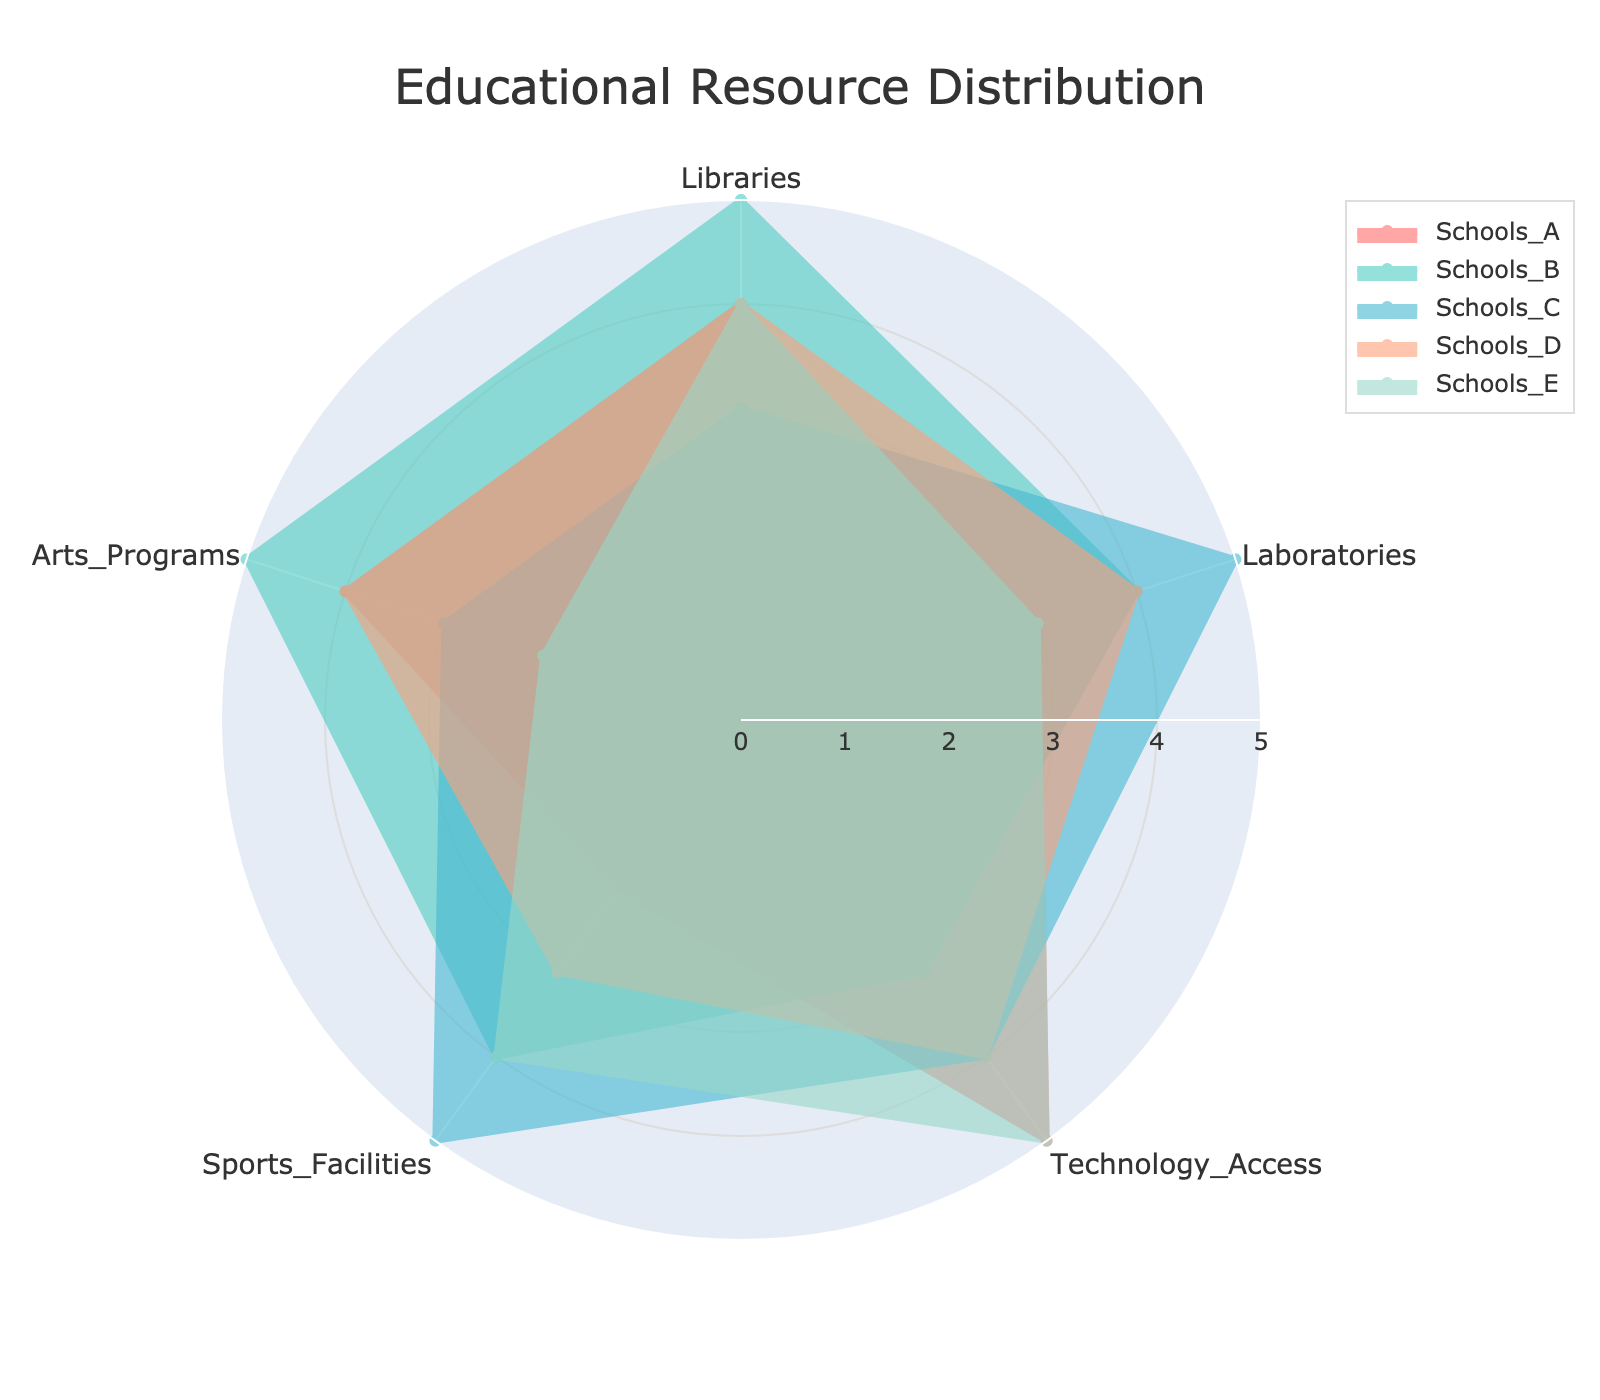What's the title of the radar chart? The title is usually placed at the top center of the figure. In this case, the title is given as "Educational Resource Distribution".
Answer: Educational Resource Distribution Which school has the highest rating for Laboratories? The category Laboratories has ratings from multiple schools. By visually comparing, School C has a rating of 5, which is the highest.
Answer: School C How many categories are there in the radar chart? The categories listed at the ends of the axes are five: Libraries, Laboratories, Technology Access, Sports Facilities, and Arts Programs.
Answer: 5 Which school scores the lowest in Sports Facilities, and what is the score? We need to look at the axis labeled Sports Facilities. School A has a score of 2, which is the lowest among all schools.
Answer: School A, 2 Which school has the most balanced distribution across all categories? A balanced distribution would mean the plotted area is almost circular. School D appears to have relatively even scores across all categories, with most values around 4.
Answer: School D What is the average score of School B across all categories? Adding School B's scores: 5 (Libraries) + 4 (Laboratories) + 3 (Technology Access) + 4 (Sports Facilities) + 5 (Arts Programs) totals 21. Dividing by 5 categories, the average is 21/5 = 4.2.
Answer: 4.2 Which category shows the greatest variation across different schools? We need to compare the range of scores across schools for each category. Sports Facilities have scores ranging from 2 to 5, which shows high variation.
Answer: Sports Facilities Compare the scores of Library resources between School A and School E. For Libraries, School A has a score of 4 and School E has a score of 4. Both scores are equal.
Answer: Equal (4 each) What is the total score for School E across all categories? Summing the scores of School E: 4 (Libraries) + 3 (Laboratories) + 5 (Technology Access) + 4 (Sports Facilities) + 2 (Arts Programs) totals 18.
Answer: 18 Which school has the highest overall score, considering all categories? We calculate the total score for each school and compare them:
School A: 4+3+5+2+4 = 18
School B: 5+4+3+4+5 = 21
School C: 3+5+4+5+3 = 20
School D: 4+4+4+3+4 = 19
School E: 4+3+5+4+2 = 18
School B has the highest total score of 21.
Answer: School B (21) 